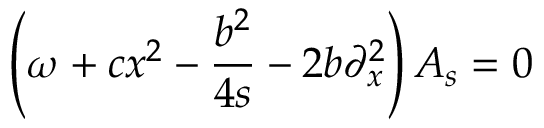<formula> <loc_0><loc_0><loc_500><loc_500>\left ( \omega + c x ^ { 2 } - \frac { b ^ { 2 } } { 4 s } - 2 b \partial _ { x } ^ { 2 } \right ) A _ { s } = 0</formula> 